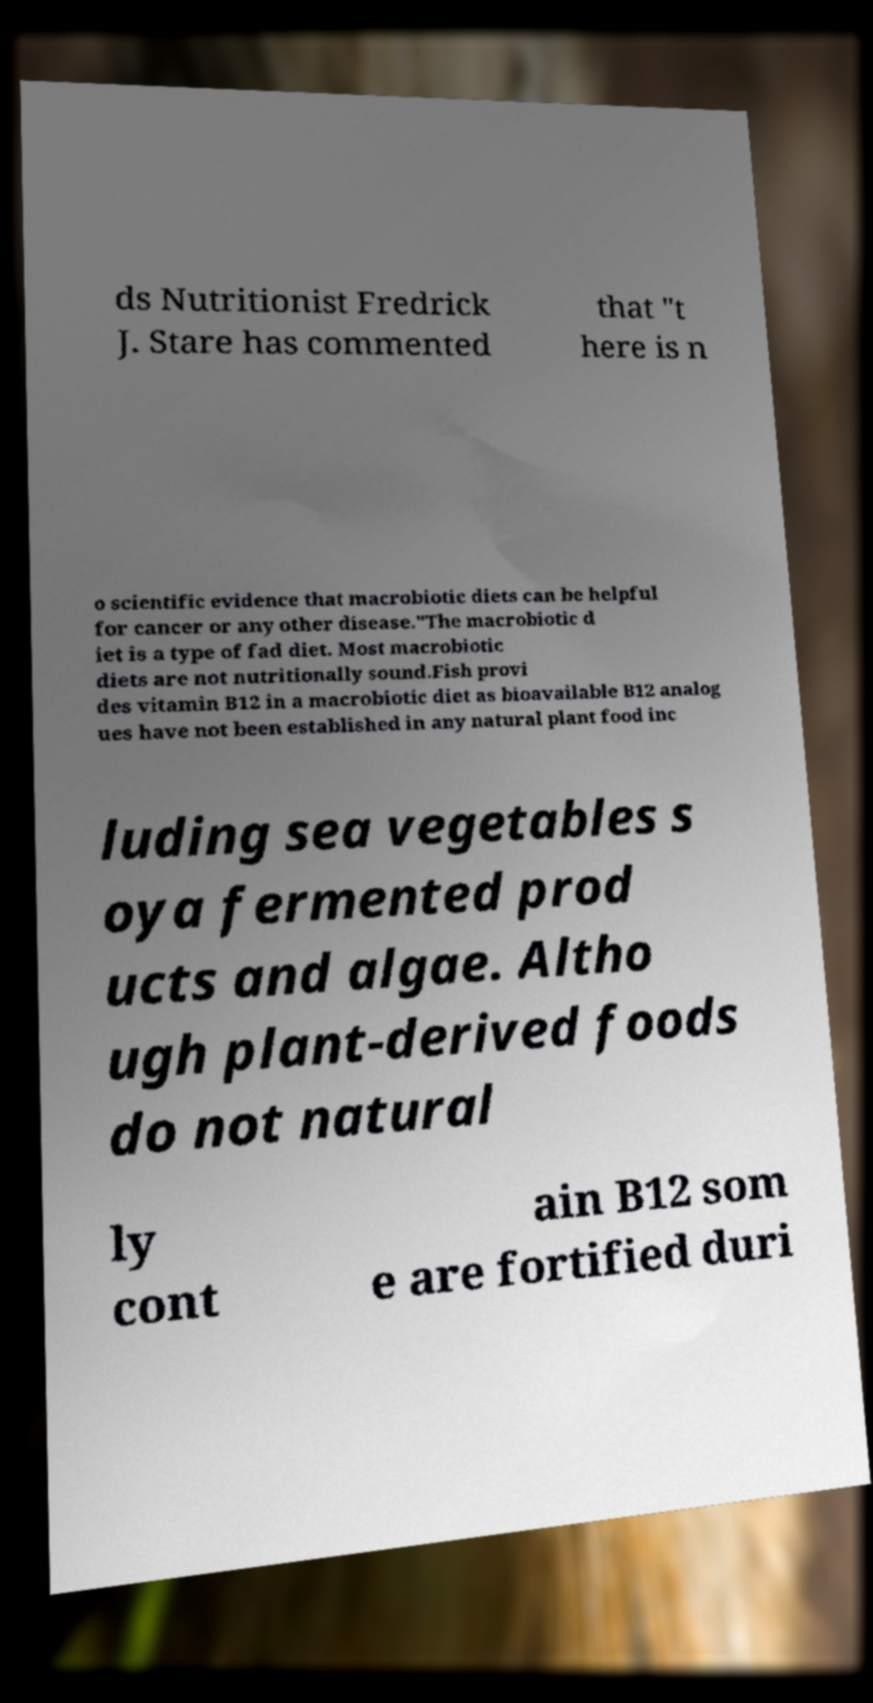Can you read and provide the text displayed in the image?This photo seems to have some interesting text. Can you extract and type it out for me? ds Nutritionist Fredrick J. Stare has commented that "t here is n o scientific evidence that macrobiotic diets can be helpful for cancer or any other disease."The macrobiotic d iet is a type of fad diet. Most macrobiotic diets are not nutritionally sound.Fish provi des vitamin B12 in a macrobiotic diet as bioavailable B12 analog ues have not been established in any natural plant food inc luding sea vegetables s oya fermented prod ucts and algae. Altho ugh plant-derived foods do not natural ly cont ain B12 som e are fortified duri 